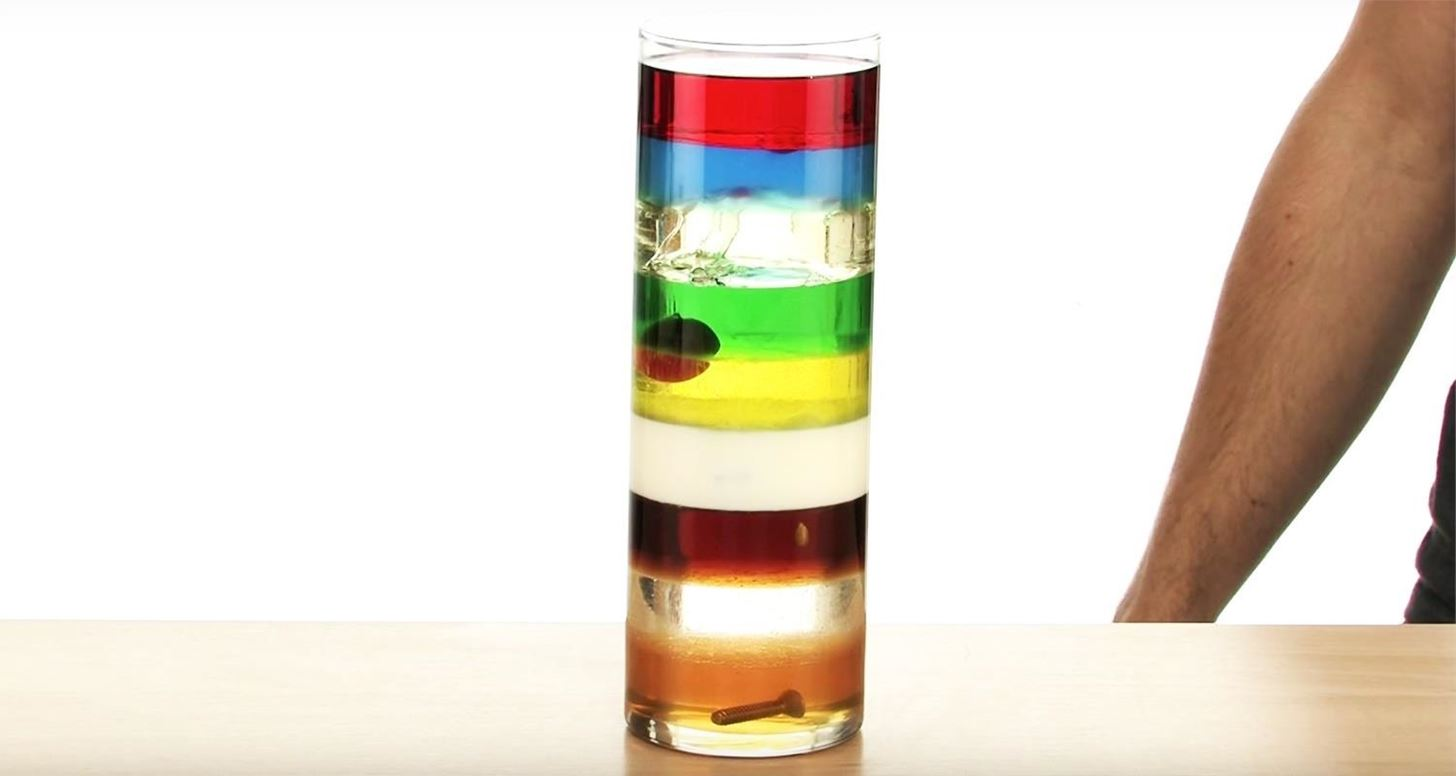If the scenario in the image was part of a universe with magical properties, what unique characteristics could the liquids possess? In a universe with magical properties, these liquids could possess imaginative and unique characteristics, such as:
- **Color-Changing Ability:** Each liquid could change color based on the energetic mood of the surroundings.
- **Sentient Movement:** The liquids could be sentient and able to move on their own to form intricate patterns without mixing uncontrollably.
- **Transmutative Properties:** Upon touching certain objects, the liquids could temporarily change the object's material properties, like turning metal into wood.
- **Time Manipulation:** Each liquid could affect the flow of time differently. Objects in contact with the red layer might age slowly, while those in the yellow layer could experience a faster passage of time.
- **Levitation Properties:** Certain layers might allow objects within them to defy gravity slightly, giving them a floating effect even outside the liquid. 